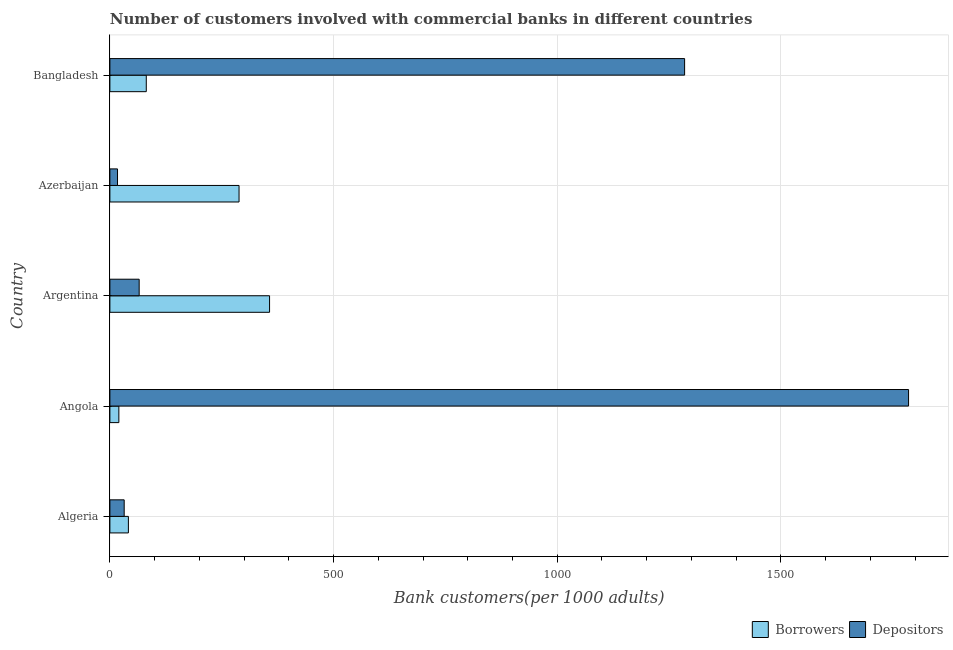How many groups of bars are there?
Make the answer very short. 5. Are the number of bars per tick equal to the number of legend labels?
Ensure brevity in your answer.  Yes. Are the number of bars on each tick of the Y-axis equal?
Ensure brevity in your answer.  Yes. How many bars are there on the 5th tick from the top?
Ensure brevity in your answer.  2. How many bars are there on the 2nd tick from the bottom?
Offer a terse response. 2. What is the label of the 5th group of bars from the top?
Provide a short and direct response. Algeria. In how many cases, is the number of bars for a given country not equal to the number of legend labels?
Your response must be concise. 0. What is the number of depositors in Algeria?
Your response must be concise. 31.96. Across all countries, what is the maximum number of depositors?
Make the answer very short. 1785.31. Across all countries, what is the minimum number of depositors?
Give a very brief answer. 17.04. In which country was the number of depositors maximum?
Offer a terse response. Angola. In which country was the number of depositors minimum?
Keep it short and to the point. Azerbaijan. What is the total number of borrowers in the graph?
Give a very brief answer. 788.38. What is the difference between the number of depositors in Angola and that in Bangladesh?
Make the answer very short. 500.6. What is the difference between the number of depositors in Angola and the number of borrowers in Argentina?
Provide a succinct answer. 1428.38. What is the average number of depositors per country?
Your answer should be compact. 636.89. What is the difference between the number of borrowers and number of depositors in Argentina?
Ensure brevity in your answer.  291.48. In how many countries, is the number of borrowers greater than 700 ?
Your response must be concise. 0. What is the ratio of the number of borrowers in Azerbaijan to that in Bangladesh?
Offer a very short reply. 3.55. What is the difference between the highest and the second highest number of borrowers?
Your answer should be very brief. 68.23. What is the difference between the highest and the lowest number of borrowers?
Offer a very short reply. 336.87. In how many countries, is the number of depositors greater than the average number of depositors taken over all countries?
Your answer should be very brief. 2. What does the 1st bar from the top in Argentina represents?
Keep it short and to the point. Depositors. What does the 1st bar from the bottom in Azerbaijan represents?
Your response must be concise. Borrowers. How many bars are there?
Your answer should be very brief. 10. Are the values on the major ticks of X-axis written in scientific E-notation?
Give a very brief answer. No. Where does the legend appear in the graph?
Your answer should be very brief. Bottom right. What is the title of the graph?
Keep it short and to the point. Number of customers involved with commercial banks in different countries. What is the label or title of the X-axis?
Offer a terse response. Bank customers(per 1000 adults). What is the label or title of the Y-axis?
Provide a succinct answer. Country. What is the Bank customers(per 1000 adults) of Borrowers in Algeria?
Keep it short and to the point. 41.34. What is the Bank customers(per 1000 adults) in Depositors in Algeria?
Provide a short and direct response. 31.96. What is the Bank customers(per 1000 adults) of Borrowers in Angola?
Offer a terse response. 20.06. What is the Bank customers(per 1000 adults) of Depositors in Angola?
Give a very brief answer. 1785.31. What is the Bank customers(per 1000 adults) of Borrowers in Argentina?
Keep it short and to the point. 356.93. What is the Bank customers(per 1000 adults) of Depositors in Argentina?
Keep it short and to the point. 65.45. What is the Bank customers(per 1000 adults) in Borrowers in Azerbaijan?
Provide a short and direct response. 288.7. What is the Bank customers(per 1000 adults) of Depositors in Azerbaijan?
Offer a terse response. 17.04. What is the Bank customers(per 1000 adults) in Borrowers in Bangladesh?
Give a very brief answer. 81.34. What is the Bank customers(per 1000 adults) of Depositors in Bangladesh?
Offer a terse response. 1284.71. Across all countries, what is the maximum Bank customers(per 1000 adults) in Borrowers?
Provide a succinct answer. 356.93. Across all countries, what is the maximum Bank customers(per 1000 adults) in Depositors?
Provide a short and direct response. 1785.31. Across all countries, what is the minimum Bank customers(per 1000 adults) in Borrowers?
Your answer should be very brief. 20.06. Across all countries, what is the minimum Bank customers(per 1000 adults) of Depositors?
Provide a short and direct response. 17.04. What is the total Bank customers(per 1000 adults) of Borrowers in the graph?
Your answer should be very brief. 788.38. What is the total Bank customers(per 1000 adults) of Depositors in the graph?
Your answer should be compact. 3184.47. What is the difference between the Bank customers(per 1000 adults) in Borrowers in Algeria and that in Angola?
Your response must be concise. 21.28. What is the difference between the Bank customers(per 1000 adults) in Depositors in Algeria and that in Angola?
Provide a succinct answer. -1753.35. What is the difference between the Bank customers(per 1000 adults) in Borrowers in Algeria and that in Argentina?
Your response must be concise. -315.59. What is the difference between the Bank customers(per 1000 adults) in Depositors in Algeria and that in Argentina?
Give a very brief answer. -33.49. What is the difference between the Bank customers(per 1000 adults) of Borrowers in Algeria and that in Azerbaijan?
Provide a short and direct response. -247.36. What is the difference between the Bank customers(per 1000 adults) of Depositors in Algeria and that in Azerbaijan?
Make the answer very short. 14.92. What is the difference between the Bank customers(per 1000 adults) of Borrowers in Algeria and that in Bangladesh?
Keep it short and to the point. -40. What is the difference between the Bank customers(per 1000 adults) in Depositors in Algeria and that in Bangladesh?
Your answer should be compact. -1252.75. What is the difference between the Bank customers(per 1000 adults) of Borrowers in Angola and that in Argentina?
Your answer should be very brief. -336.87. What is the difference between the Bank customers(per 1000 adults) of Depositors in Angola and that in Argentina?
Keep it short and to the point. 1719.86. What is the difference between the Bank customers(per 1000 adults) in Borrowers in Angola and that in Azerbaijan?
Provide a short and direct response. -268.64. What is the difference between the Bank customers(per 1000 adults) of Depositors in Angola and that in Azerbaijan?
Offer a terse response. 1768.27. What is the difference between the Bank customers(per 1000 adults) of Borrowers in Angola and that in Bangladesh?
Make the answer very short. -61.29. What is the difference between the Bank customers(per 1000 adults) of Depositors in Angola and that in Bangladesh?
Your response must be concise. 500.6. What is the difference between the Bank customers(per 1000 adults) of Borrowers in Argentina and that in Azerbaijan?
Ensure brevity in your answer.  68.23. What is the difference between the Bank customers(per 1000 adults) of Depositors in Argentina and that in Azerbaijan?
Keep it short and to the point. 48.41. What is the difference between the Bank customers(per 1000 adults) of Borrowers in Argentina and that in Bangladesh?
Keep it short and to the point. 275.59. What is the difference between the Bank customers(per 1000 adults) in Depositors in Argentina and that in Bangladesh?
Provide a succinct answer. -1219.26. What is the difference between the Bank customers(per 1000 adults) of Borrowers in Azerbaijan and that in Bangladesh?
Give a very brief answer. 207.36. What is the difference between the Bank customers(per 1000 adults) in Depositors in Azerbaijan and that in Bangladesh?
Offer a terse response. -1267.67. What is the difference between the Bank customers(per 1000 adults) of Borrowers in Algeria and the Bank customers(per 1000 adults) of Depositors in Angola?
Provide a succinct answer. -1743.97. What is the difference between the Bank customers(per 1000 adults) in Borrowers in Algeria and the Bank customers(per 1000 adults) in Depositors in Argentina?
Your answer should be compact. -24.11. What is the difference between the Bank customers(per 1000 adults) of Borrowers in Algeria and the Bank customers(per 1000 adults) of Depositors in Azerbaijan?
Provide a short and direct response. 24.3. What is the difference between the Bank customers(per 1000 adults) in Borrowers in Algeria and the Bank customers(per 1000 adults) in Depositors in Bangladesh?
Your answer should be compact. -1243.37. What is the difference between the Bank customers(per 1000 adults) in Borrowers in Angola and the Bank customers(per 1000 adults) in Depositors in Argentina?
Make the answer very short. -45.39. What is the difference between the Bank customers(per 1000 adults) of Borrowers in Angola and the Bank customers(per 1000 adults) of Depositors in Azerbaijan?
Ensure brevity in your answer.  3.02. What is the difference between the Bank customers(per 1000 adults) in Borrowers in Angola and the Bank customers(per 1000 adults) in Depositors in Bangladesh?
Offer a very short reply. -1264.65. What is the difference between the Bank customers(per 1000 adults) in Borrowers in Argentina and the Bank customers(per 1000 adults) in Depositors in Azerbaijan?
Keep it short and to the point. 339.89. What is the difference between the Bank customers(per 1000 adults) in Borrowers in Argentina and the Bank customers(per 1000 adults) in Depositors in Bangladesh?
Your response must be concise. -927.78. What is the difference between the Bank customers(per 1000 adults) of Borrowers in Azerbaijan and the Bank customers(per 1000 adults) of Depositors in Bangladesh?
Make the answer very short. -996. What is the average Bank customers(per 1000 adults) of Borrowers per country?
Ensure brevity in your answer.  157.68. What is the average Bank customers(per 1000 adults) in Depositors per country?
Your response must be concise. 636.89. What is the difference between the Bank customers(per 1000 adults) of Borrowers and Bank customers(per 1000 adults) of Depositors in Algeria?
Give a very brief answer. 9.38. What is the difference between the Bank customers(per 1000 adults) in Borrowers and Bank customers(per 1000 adults) in Depositors in Angola?
Offer a terse response. -1765.25. What is the difference between the Bank customers(per 1000 adults) in Borrowers and Bank customers(per 1000 adults) in Depositors in Argentina?
Provide a short and direct response. 291.48. What is the difference between the Bank customers(per 1000 adults) in Borrowers and Bank customers(per 1000 adults) in Depositors in Azerbaijan?
Provide a succinct answer. 271.66. What is the difference between the Bank customers(per 1000 adults) in Borrowers and Bank customers(per 1000 adults) in Depositors in Bangladesh?
Offer a terse response. -1203.36. What is the ratio of the Bank customers(per 1000 adults) in Borrowers in Algeria to that in Angola?
Offer a very short reply. 2.06. What is the ratio of the Bank customers(per 1000 adults) of Depositors in Algeria to that in Angola?
Your answer should be very brief. 0.02. What is the ratio of the Bank customers(per 1000 adults) in Borrowers in Algeria to that in Argentina?
Offer a very short reply. 0.12. What is the ratio of the Bank customers(per 1000 adults) of Depositors in Algeria to that in Argentina?
Give a very brief answer. 0.49. What is the ratio of the Bank customers(per 1000 adults) in Borrowers in Algeria to that in Azerbaijan?
Ensure brevity in your answer.  0.14. What is the ratio of the Bank customers(per 1000 adults) of Depositors in Algeria to that in Azerbaijan?
Ensure brevity in your answer.  1.88. What is the ratio of the Bank customers(per 1000 adults) in Borrowers in Algeria to that in Bangladesh?
Make the answer very short. 0.51. What is the ratio of the Bank customers(per 1000 adults) of Depositors in Algeria to that in Bangladesh?
Provide a short and direct response. 0.02. What is the ratio of the Bank customers(per 1000 adults) in Borrowers in Angola to that in Argentina?
Your response must be concise. 0.06. What is the ratio of the Bank customers(per 1000 adults) in Depositors in Angola to that in Argentina?
Make the answer very short. 27.28. What is the ratio of the Bank customers(per 1000 adults) in Borrowers in Angola to that in Azerbaijan?
Provide a short and direct response. 0.07. What is the ratio of the Bank customers(per 1000 adults) of Depositors in Angola to that in Azerbaijan?
Your answer should be very brief. 104.76. What is the ratio of the Bank customers(per 1000 adults) in Borrowers in Angola to that in Bangladesh?
Keep it short and to the point. 0.25. What is the ratio of the Bank customers(per 1000 adults) of Depositors in Angola to that in Bangladesh?
Your response must be concise. 1.39. What is the ratio of the Bank customers(per 1000 adults) in Borrowers in Argentina to that in Azerbaijan?
Keep it short and to the point. 1.24. What is the ratio of the Bank customers(per 1000 adults) in Depositors in Argentina to that in Azerbaijan?
Provide a short and direct response. 3.84. What is the ratio of the Bank customers(per 1000 adults) of Borrowers in Argentina to that in Bangladesh?
Your answer should be compact. 4.39. What is the ratio of the Bank customers(per 1000 adults) of Depositors in Argentina to that in Bangladesh?
Ensure brevity in your answer.  0.05. What is the ratio of the Bank customers(per 1000 adults) in Borrowers in Azerbaijan to that in Bangladesh?
Keep it short and to the point. 3.55. What is the ratio of the Bank customers(per 1000 adults) of Depositors in Azerbaijan to that in Bangladesh?
Your answer should be very brief. 0.01. What is the difference between the highest and the second highest Bank customers(per 1000 adults) in Borrowers?
Provide a short and direct response. 68.23. What is the difference between the highest and the second highest Bank customers(per 1000 adults) in Depositors?
Make the answer very short. 500.6. What is the difference between the highest and the lowest Bank customers(per 1000 adults) of Borrowers?
Provide a short and direct response. 336.87. What is the difference between the highest and the lowest Bank customers(per 1000 adults) of Depositors?
Your answer should be compact. 1768.27. 